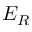<formula> <loc_0><loc_0><loc_500><loc_500>E _ { R }</formula> 